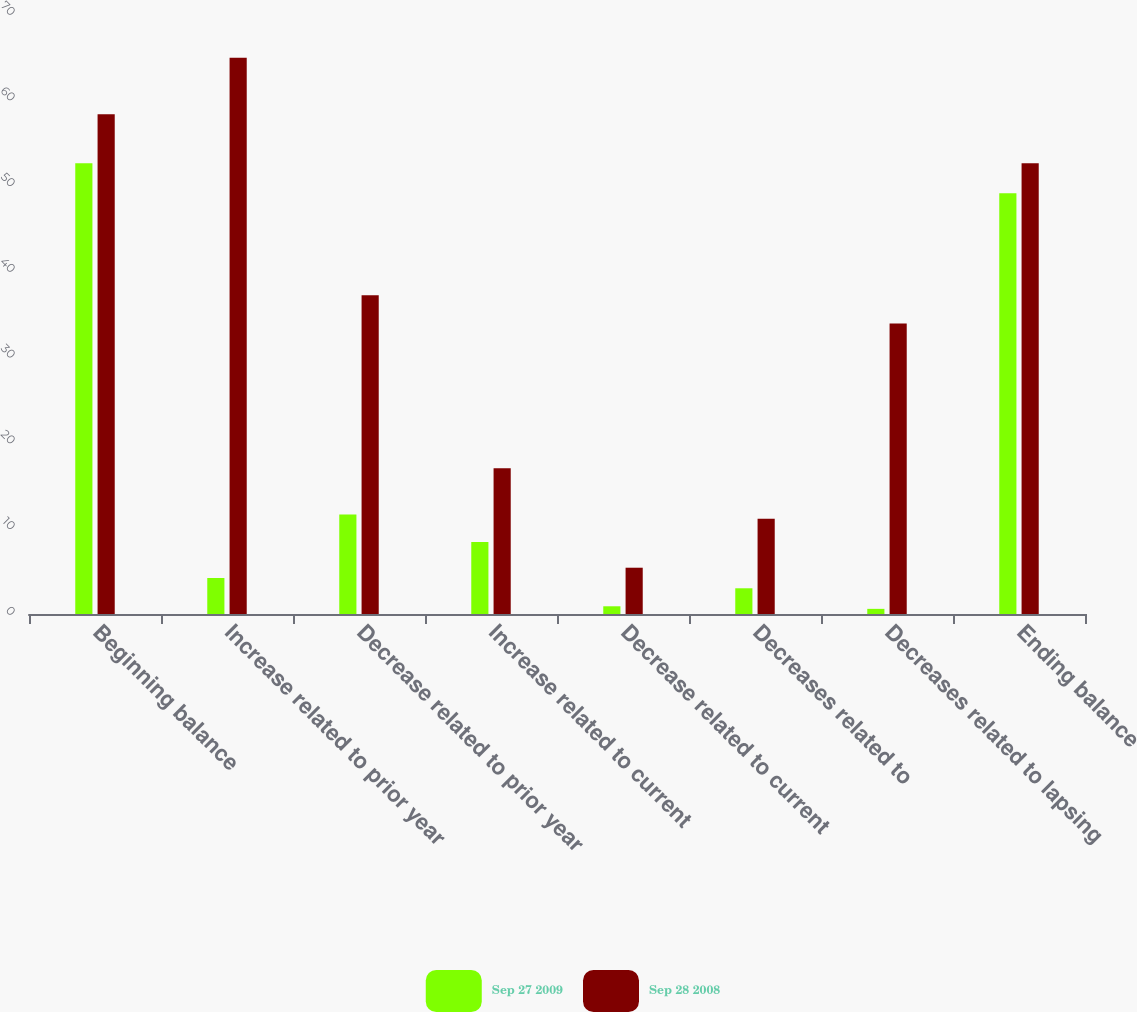Convert chart. <chart><loc_0><loc_0><loc_500><loc_500><stacked_bar_chart><ecel><fcel>Beginning balance<fcel>Increase related to prior year<fcel>Decrease related to prior year<fcel>Increase related to current<fcel>Decrease related to current<fcel>Decreases related to<fcel>Decreases related to lapsing<fcel>Ending balance<nl><fcel>Sep 27 2009<fcel>52.6<fcel>4.2<fcel>11.6<fcel>8.4<fcel>0.9<fcel>3<fcel>0.6<fcel>49.1<nl><fcel>Sep 28 2008<fcel>58.3<fcel>64.9<fcel>37.2<fcel>17<fcel>5.4<fcel>11.1<fcel>33.9<fcel>52.6<nl></chart> 